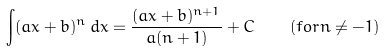Convert formula to latex. <formula><loc_0><loc_0><loc_500><loc_500>\int ( a x + b ) ^ { n } \, d x = { \frac { ( a x + b ) ^ { n + 1 } } { a ( n + 1 ) } } + C \quad { ( f o r } n \neq - 1 { ) }</formula> 